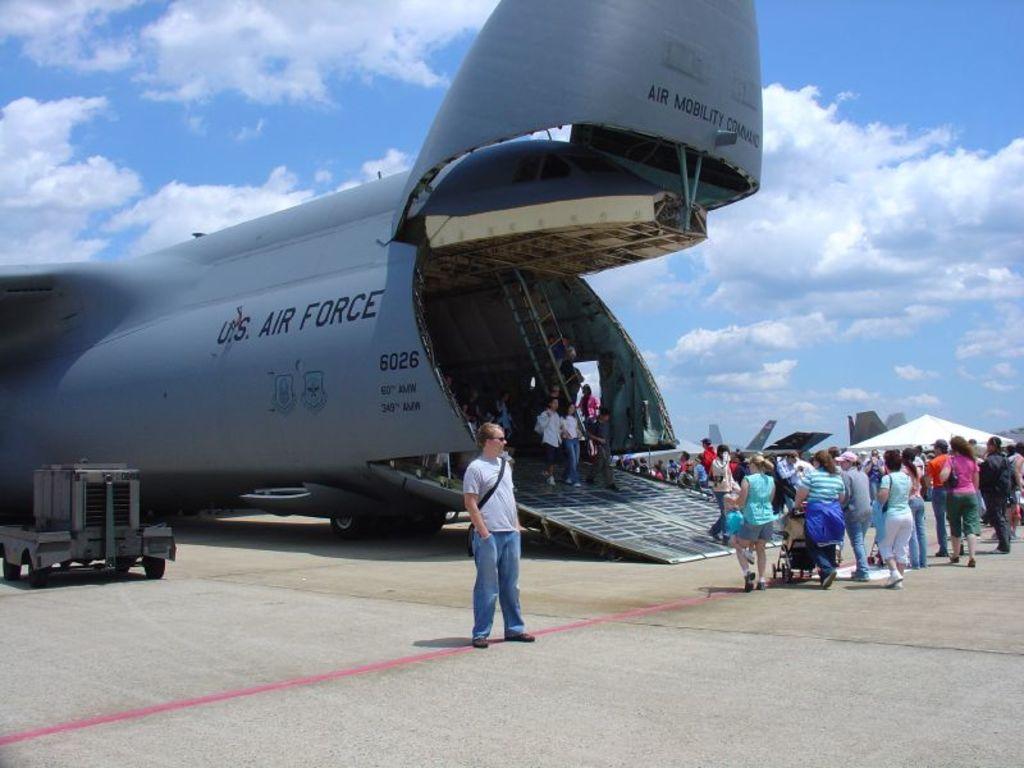Who does the plane belong to?
Provide a short and direct response. Us air force. What number is on the side of the plane?
Offer a very short reply. 6026. 